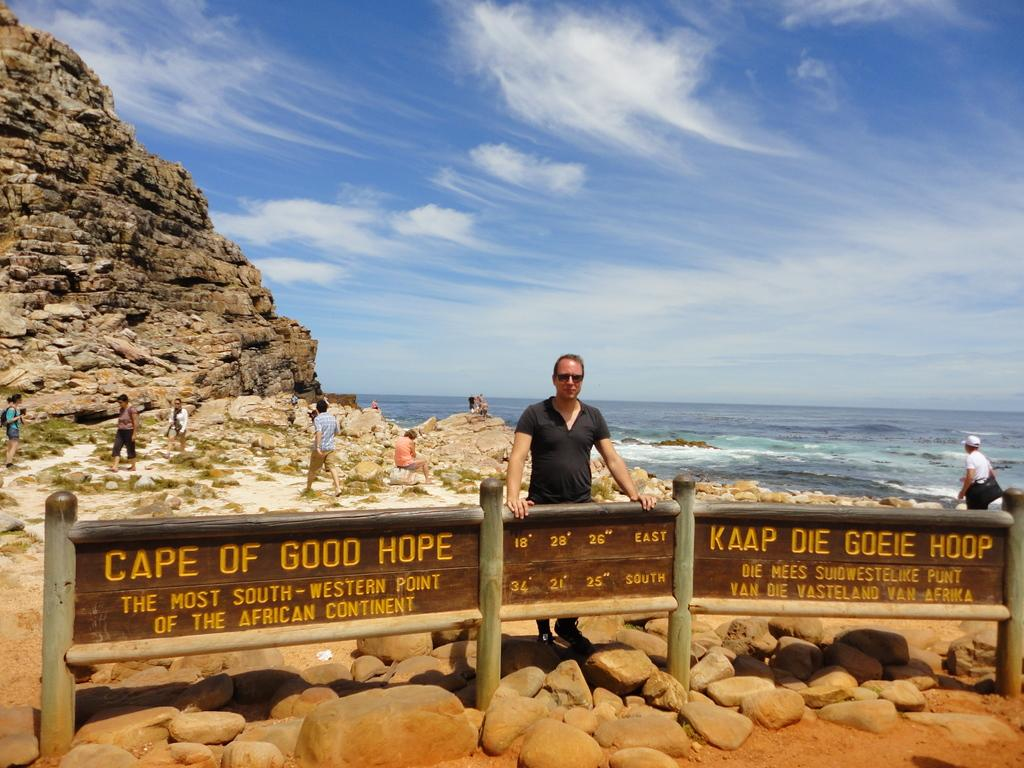What is the main subject of the image? There is a man standing in the image. Can you describe the man's surroundings? The man is in front of a boundary, and there are stones in the foreground area of the image. Are there any other people visible in the image? Yes, there are people visible in the image. What type of terrain is depicted in the image? The image appears to depict a hill. What can be seen in the background of the image? The sky is visible in the background of the image. What type of wine is being served at the expansion event in the image? There is no mention of an expansion event or wine in the image. The image depicts a man standing in front of a boundary with stones and people visible in the background. 